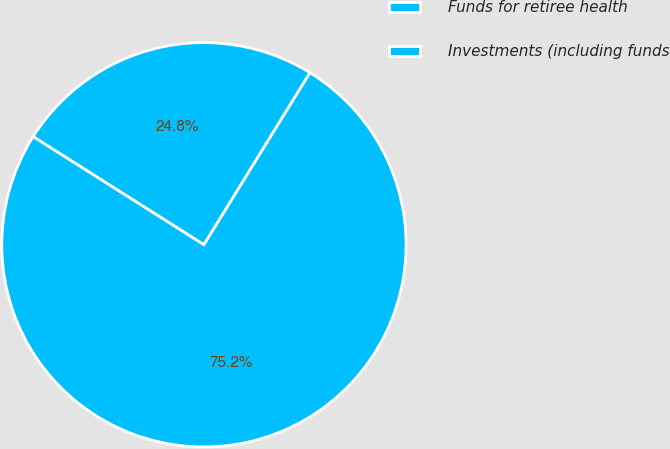<chart> <loc_0><loc_0><loc_500><loc_500><pie_chart><fcel>Funds for retiree health<fcel>Investments (including funds<nl><fcel>24.81%<fcel>75.19%<nl></chart> 